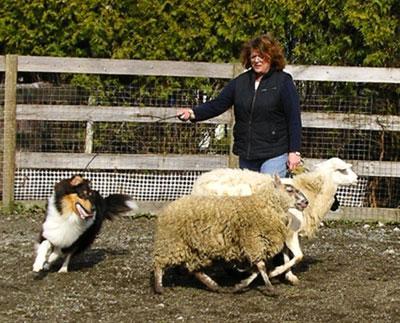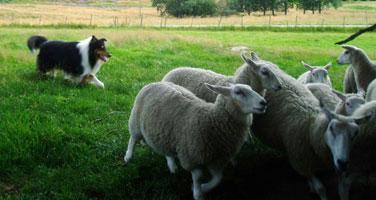The first image is the image on the left, the second image is the image on the right. Analyze the images presented: Is the assertion "An image features a person standing in front of a plank fence and behind multiple sheep, with a dog nearby." valid? Answer yes or no. Yes. The first image is the image on the left, the second image is the image on the right. Analyze the images presented: Is the assertion "The right image contains a dog chasing sheep towards the right." valid? Answer yes or no. Yes. 